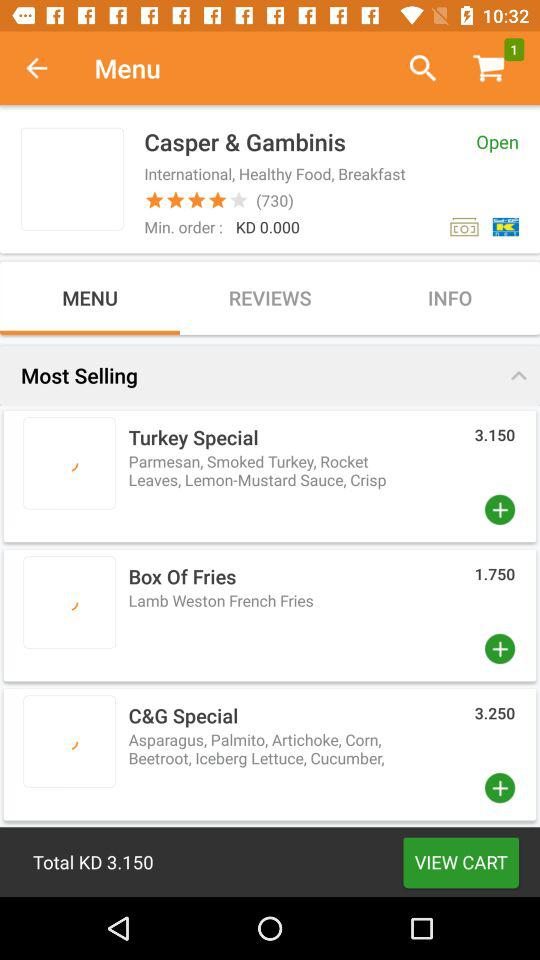What is the minimum order value? The minimum order value is KD 0. 